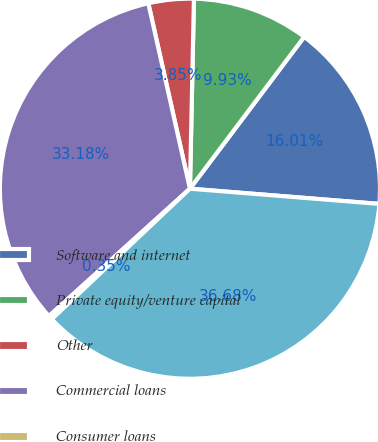<chart> <loc_0><loc_0><loc_500><loc_500><pie_chart><fcel>Software and internet<fcel>Private equity/venture capital<fcel>Other<fcel>Commercial loans<fcel>Consumer loans<fcel>Total gross loans<nl><fcel>16.01%<fcel>9.93%<fcel>3.85%<fcel>33.18%<fcel>0.35%<fcel>36.68%<nl></chart> 